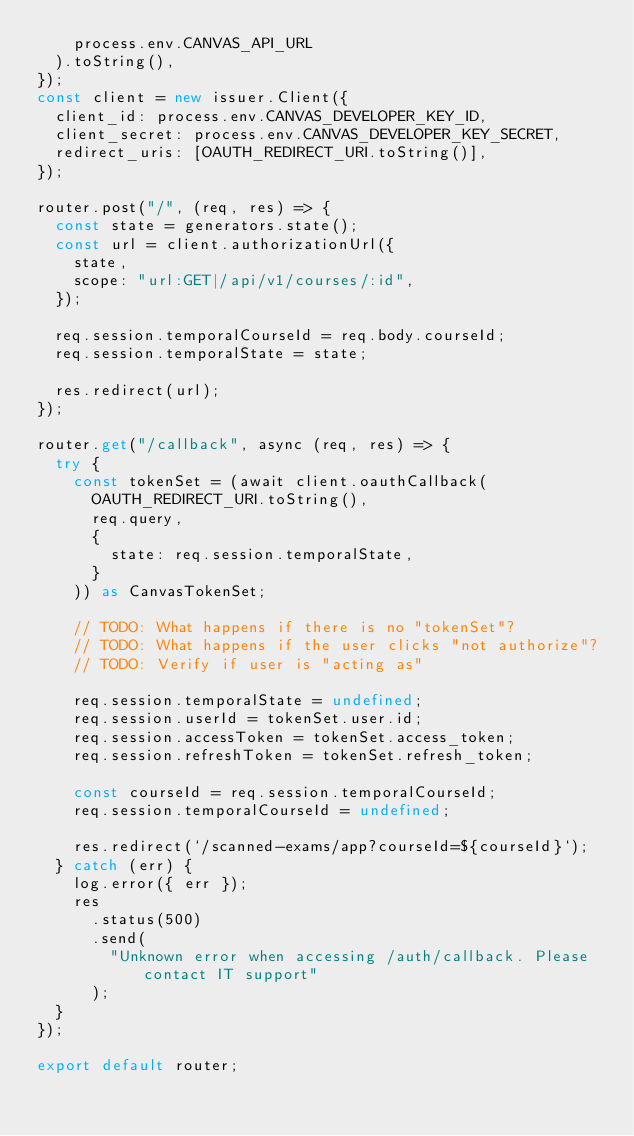Convert code to text. <code><loc_0><loc_0><loc_500><loc_500><_TypeScript_>    process.env.CANVAS_API_URL
  ).toString(),
});
const client = new issuer.Client({
  client_id: process.env.CANVAS_DEVELOPER_KEY_ID,
  client_secret: process.env.CANVAS_DEVELOPER_KEY_SECRET,
  redirect_uris: [OAUTH_REDIRECT_URI.toString()],
});

router.post("/", (req, res) => {
  const state = generators.state();
  const url = client.authorizationUrl({
    state,
    scope: "url:GET|/api/v1/courses/:id",
  });

  req.session.temporalCourseId = req.body.courseId;
  req.session.temporalState = state;

  res.redirect(url);
});

router.get("/callback", async (req, res) => {
  try {
    const tokenSet = (await client.oauthCallback(
      OAUTH_REDIRECT_URI.toString(),
      req.query,
      {
        state: req.session.temporalState,
      }
    )) as CanvasTokenSet;

    // TODO: What happens if there is no "tokenSet"?
    // TODO: What happens if the user clicks "not authorize"?
    // TODO: Verify if user is "acting as"

    req.session.temporalState = undefined;
    req.session.userId = tokenSet.user.id;
    req.session.accessToken = tokenSet.access_token;
    req.session.refreshToken = tokenSet.refresh_token;

    const courseId = req.session.temporalCourseId;
    req.session.temporalCourseId = undefined;

    res.redirect(`/scanned-exams/app?courseId=${courseId}`);
  } catch (err) {
    log.error({ err });
    res
      .status(500)
      .send(
        "Unknown error when accessing /auth/callback. Please contact IT support"
      );
  }
});

export default router;
</code> 